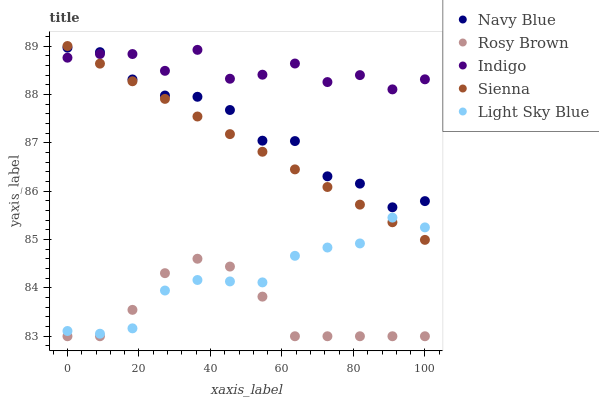Does Rosy Brown have the minimum area under the curve?
Answer yes or no. Yes. Does Indigo have the maximum area under the curve?
Answer yes or no. Yes. Does Navy Blue have the minimum area under the curve?
Answer yes or no. No. Does Navy Blue have the maximum area under the curve?
Answer yes or no. No. Is Sienna the smoothest?
Answer yes or no. Yes. Is Indigo the roughest?
Answer yes or no. Yes. Is Navy Blue the smoothest?
Answer yes or no. No. Is Navy Blue the roughest?
Answer yes or no. No. Does Rosy Brown have the lowest value?
Answer yes or no. Yes. Does Navy Blue have the lowest value?
Answer yes or no. No. Does Sienna have the highest value?
Answer yes or no. Yes. Does Navy Blue have the highest value?
Answer yes or no. No. Is Light Sky Blue less than Navy Blue?
Answer yes or no. Yes. Is Navy Blue greater than Light Sky Blue?
Answer yes or no. Yes. Does Indigo intersect Navy Blue?
Answer yes or no. Yes. Is Indigo less than Navy Blue?
Answer yes or no. No. Is Indigo greater than Navy Blue?
Answer yes or no. No. Does Light Sky Blue intersect Navy Blue?
Answer yes or no. No. 